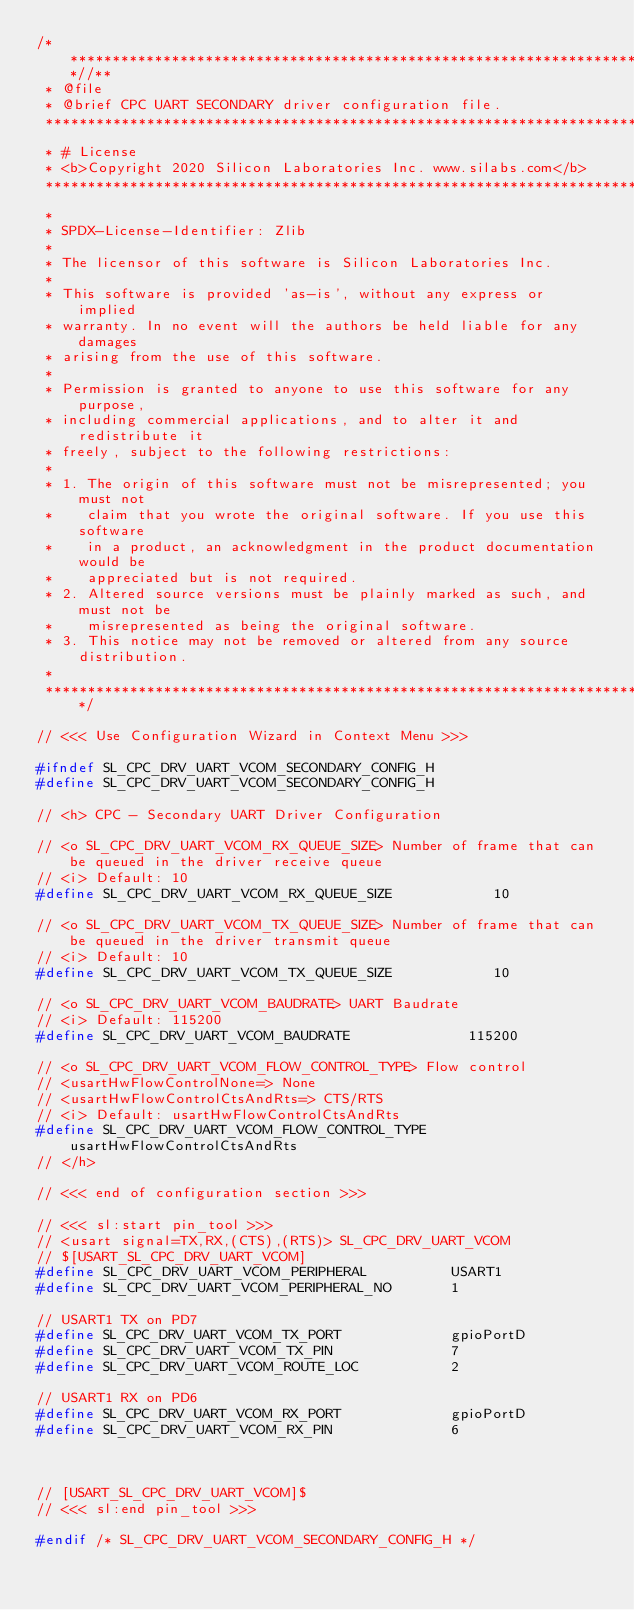Convert code to text. <code><loc_0><loc_0><loc_500><loc_500><_C_>/***************************************************************************//**
 * @file
 * @brief CPC UART SECONDARY driver configuration file.
 *******************************************************************************
 * # License
 * <b>Copyright 2020 Silicon Laboratories Inc. www.silabs.com</b>
 *******************************************************************************
 *
 * SPDX-License-Identifier: Zlib
 *
 * The licensor of this software is Silicon Laboratories Inc.
 *
 * This software is provided 'as-is', without any express or implied
 * warranty. In no event will the authors be held liable for any damages
 * arising from the use of this software.
 *
 * Permission is granted to anyone to use this software for any purpose,
 * including commercial applications, and to alter it and redistribute it
 * freely, subject to the following restrictions:
 *
 * 1. The origin of this software must not be misrepresented; you must not
 *    claim that you wrote the original software. If you use this software
 *    in a product, an acknowledgment in the product documentation would be
 *    appreciated but is not required.
 * 2. Altered source versions must be plainly marked as such, and must not be
 *    misrepresented as being the original software.
 * 3. This notice may not be removed or altered from any source distribution.
 *
 ******************************************************************************/

// <<< Use Configuration Wizard in Context Menu >>>

#ifndef SL_CPC_DRV_UART_VCOM_SECONDARY_CONFIG_H
#define SL_CPC_DRV_UART_VCOM_SECONDARY_CONFIG_H

// <h> CPC - Secondary UART Driver Configuration

// <o SL_CPC_DRV_UART_VCOM_RX_QUEUE_SIZE> Number of frame that can be queued in the driver receive queue
// <i> Default: 10
#define SL_CPC_DRV_UART_VCOM_RX_QUEUE_SIZE            10

// <o SL_CPC_DRV_UART_VCOM_TX_QUEUE_SIZE> Number of frame that can be queued in the driver transmit queue
// <i> Default: 10
#define SL_CPC_DRV_UART_VCOM_TX_QUEUE_SIZE            10

// <o SL_CPC_DRV_UART_VCOM_BAUDRATE> UART Baudrate
// <i> Default: 115200
#define SL_CPC_DRV_UART_VCOM_BAUDRATE              115200

// <o SL_CPC_DRV_UART_VCOM_FLOW_CONTROL_TYPE> Flow control
// <usartHwFlowControlNone=> None
// <usartHwFlowControlCtsAndRts=> CTS/RTS
// <i> Default: usartHwFlowControlCtsAndRts
#define SL_CPC_DRV_UART_VCOM_FLOW_CONTROL_TYPE usartHwFlowControlCtsAndRts
// </h>

// <<< end of configuration section >>>

// <<< sl:start pin_tool >>>
// <usart signal=TX,RX,(CTS),(RTS)> SL_CPC_DRV_UART_VCOM
// $[USART_SL_CPC_DRV_UART_VCOM]
#define SL_CPC_DRV_UART_VCOM_PERIPHERAL          USART1
#define SL_CPC_DRV_UART_VCOM_PERIPHERAL_NO       1

// USART1 TX on PD7
#define SL_CPC_DRV_UART_VCOM_TX_PORT             gpioPortD
#define SL_CPC_DRV_UART_VCOM_TX_PIN              7
#define SL_CPC_DRV_UART_VCOM_ROUTE_LOC           2

// USART1 RX on PD6
#define SL_CPC_DRV_UART_VCOM_RX_PORT             gpioPortD
#define SL_CPC_DRV_UART_VCOM_RX_PIN              6



// [USART_SL_CPC_DRV_UART_VCOM]$
// <<< sl:end pin_tool >>>

#endif /* SL_CPC_DRV_UART_VCOM_SECONDARY_CONFIG_H */
</code> 